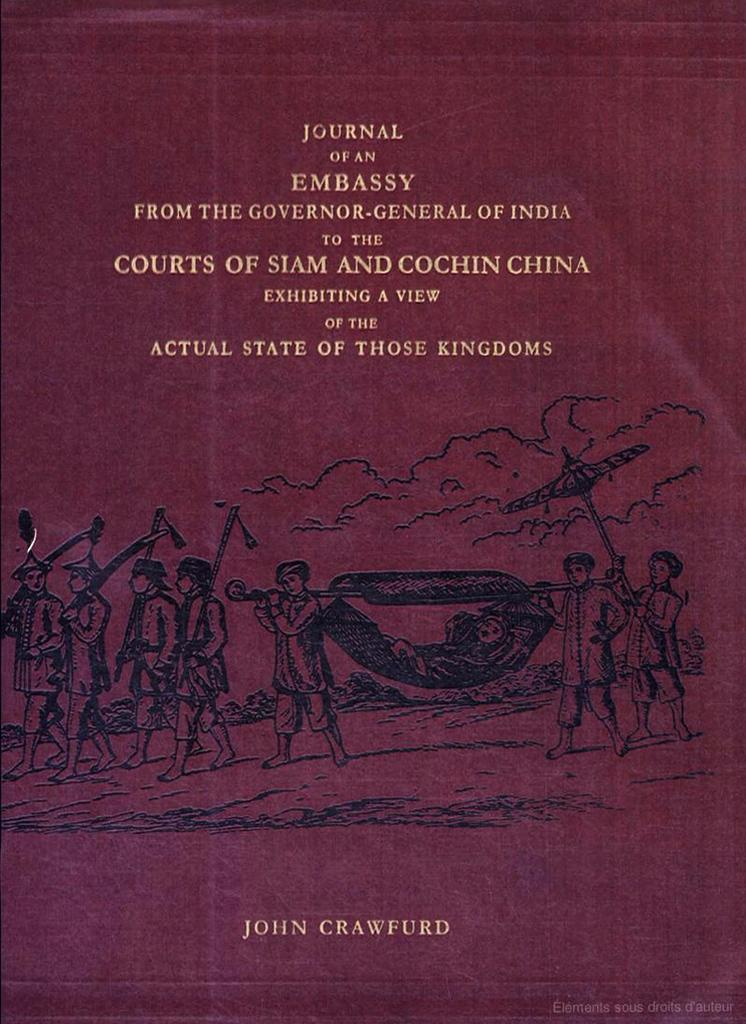<image>
Share a concise interpretation of the image provided. A diary relating to the establishment of an embassy is written by John Crawfurd. 